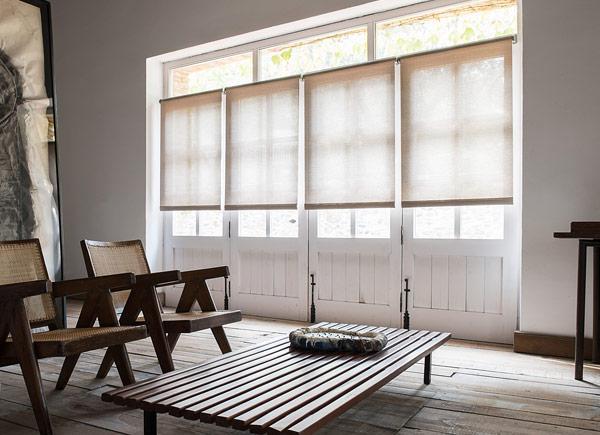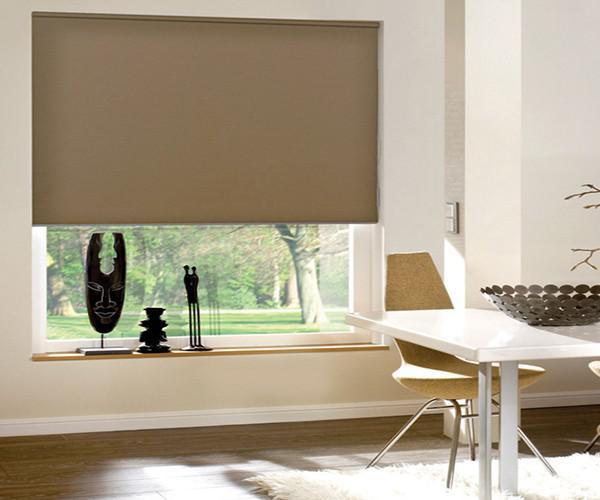The first image is the image on the left, the second image is the image on the right. Analyze the images presented: Is the assertion "There are at least four window panes in one of the images." valid? Answer yes or no. Yes. The first image is the image on the left, the second image is the image on the right. For the images shown, is this caption "In at least one image there are three blinds behind at least two chairs." true? Answer yes or no. No. 